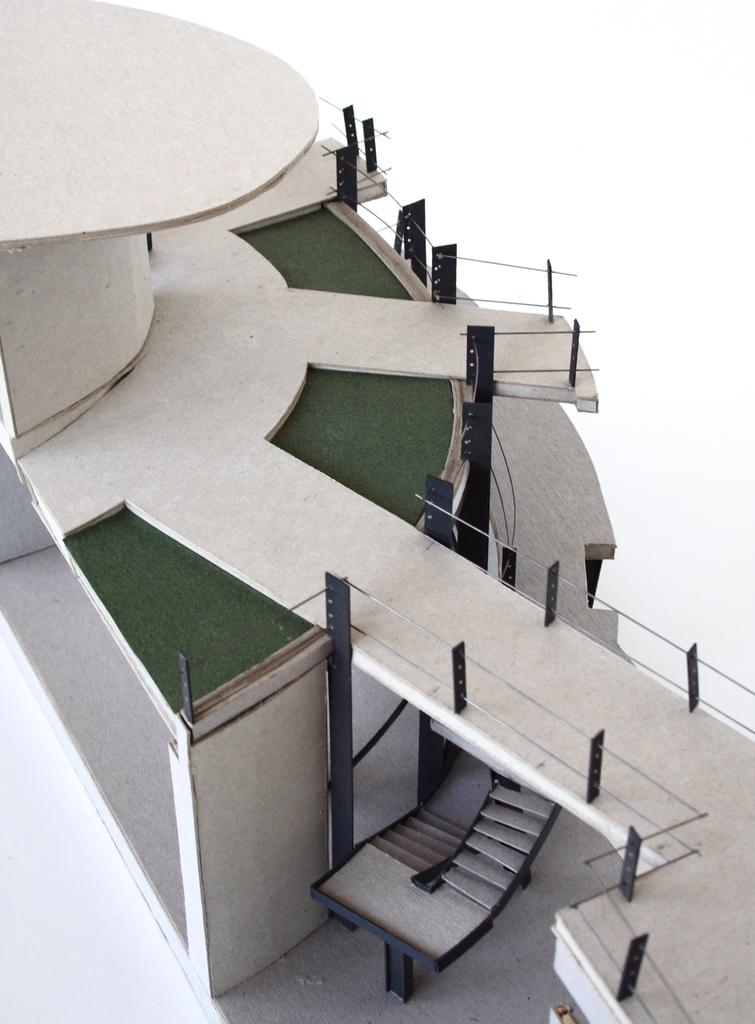What is the main subject of the image? The main subject of the image is a building craft. What color is the background of the image? The background of the image is white. What type of punishment is being given to the building craft in the image? There is no punishment being given to the building craft in the image; it is a static image of a craft. How many windows are visible on the building craft in the image? There are no windows visible on the building craft in the image, as it is a craft and not an actual building. 